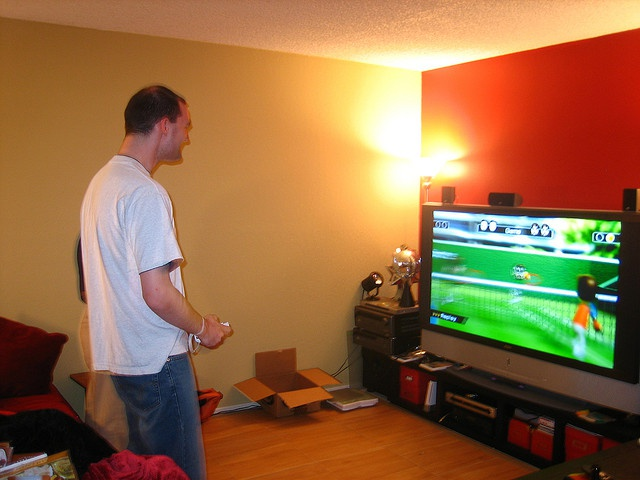Describe the objects in this image and their specific colors. I can see people in brown, black, darkgray, and pink tones, tv in brown, black, white, lightgreen, and lime tones, couch in brown, black, maroon, and olive tones, book in brown, olive, maroon, gray, and black tones, and book in brown, maroon, darkgray, black, and gray tones in this image. 